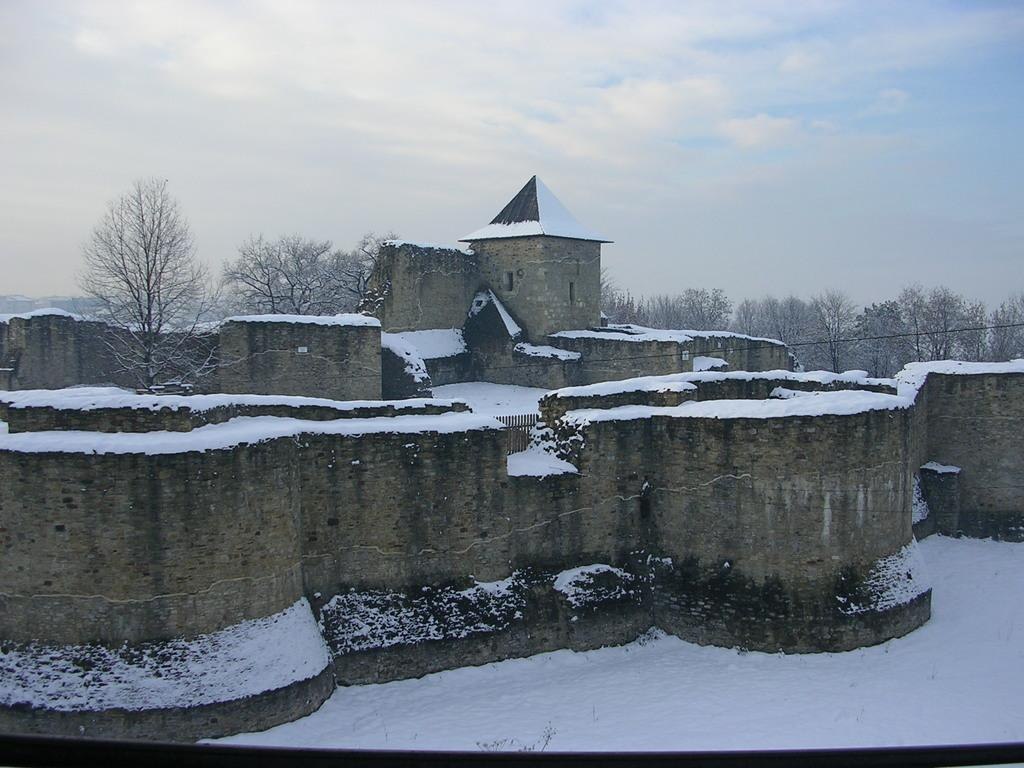What type of structure is visible in the image? There is an architectural structure in the image. How is the structure affected by the weather? The structure is covered with snow. What can be seen in the background of the image? There are trees visible behind the structure. What type of army is marching through the sand in the image? There is no army or sand present in the image; it features an architectural structure covered with snow and trees in the background. 